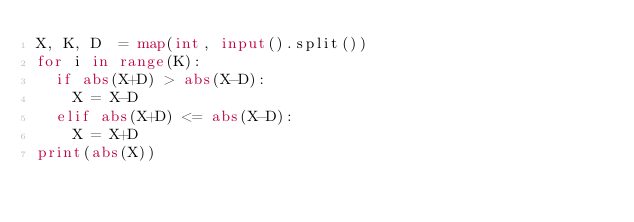Convert code to text. <code><loc_0><loc_0><loc_500><loc_500><_Python_>X, K, D  = map(int, input().split())
for i in range(K):
  if abs(X+D) > abs(X-D):
    X = X-D
  elif abs(X+D) <= abs(X-D):
    X = X+D
print(abs(X))</code> 